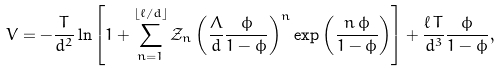Convert formula to latex. <formula><loc_0><loc_0><loc_500><loc_500>V = - \frac { T } { d ^ { 2 } } \ln \left [ 1 + \sum _ { n = 1 } ^ { \lfloor \ell / d \rfloor } \mathcal { Z } _ { n } \left ( \frac { \Lambda } { d } \frac { \phi } { 1 - \phi } \right ) ^ { n } \exp \left ( \frac { n \, \phi } { 1 - \phi } \right ) \right ] + \frac { \ell \, T } { d ^ { 3 } } \frac { \phi } { 1 - \phi } ,</formula> 